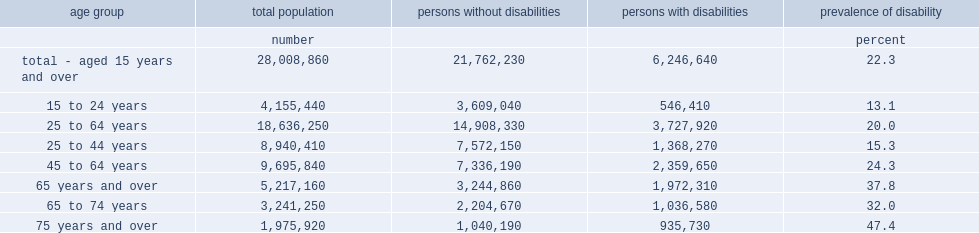What percent of the canadian population aged 15 years and over has one or more disabilities? 22.3. What is the range of disability among canadian population age 15 years and over? 13.1 47.4. What percentage of working age adults aged 25 to 64 years has a disability? 20. Help me parse the entirety of this table. {'header': ['age group', 'total population', 'persons without disabilities', 'persons with disabilities', 'prevalence of disability'], 'rows': [['', 'number', '', '', 'percent'], ['total - aged 15 years and over', '28,008,860', '21,762,230', '6,246,640', '22.3'], ['15 to 24 years', '4,155,440', '3,609,040', '546,410', '13.1'], ['25 to 64 years', '18,636,250', '14,908,330', '3,727,920', '20.0'], ['25 to 44 years', '8,940,410', '7,572,150', '1,368,270', '15.3'], ['45 to 64 years', '9,695,840', '7,336,190', '2,359,650', '24.3'], ['65 years and over', '5,217,160', '3,244,860', '1,972,310', '37.8'], ['65 to 74 years', '3,241,250', '2,204,670', '1,036,580', '32.0'], ['75 years and over', '1,975,920', '1,040,190', '935,730', '47.4']]} 